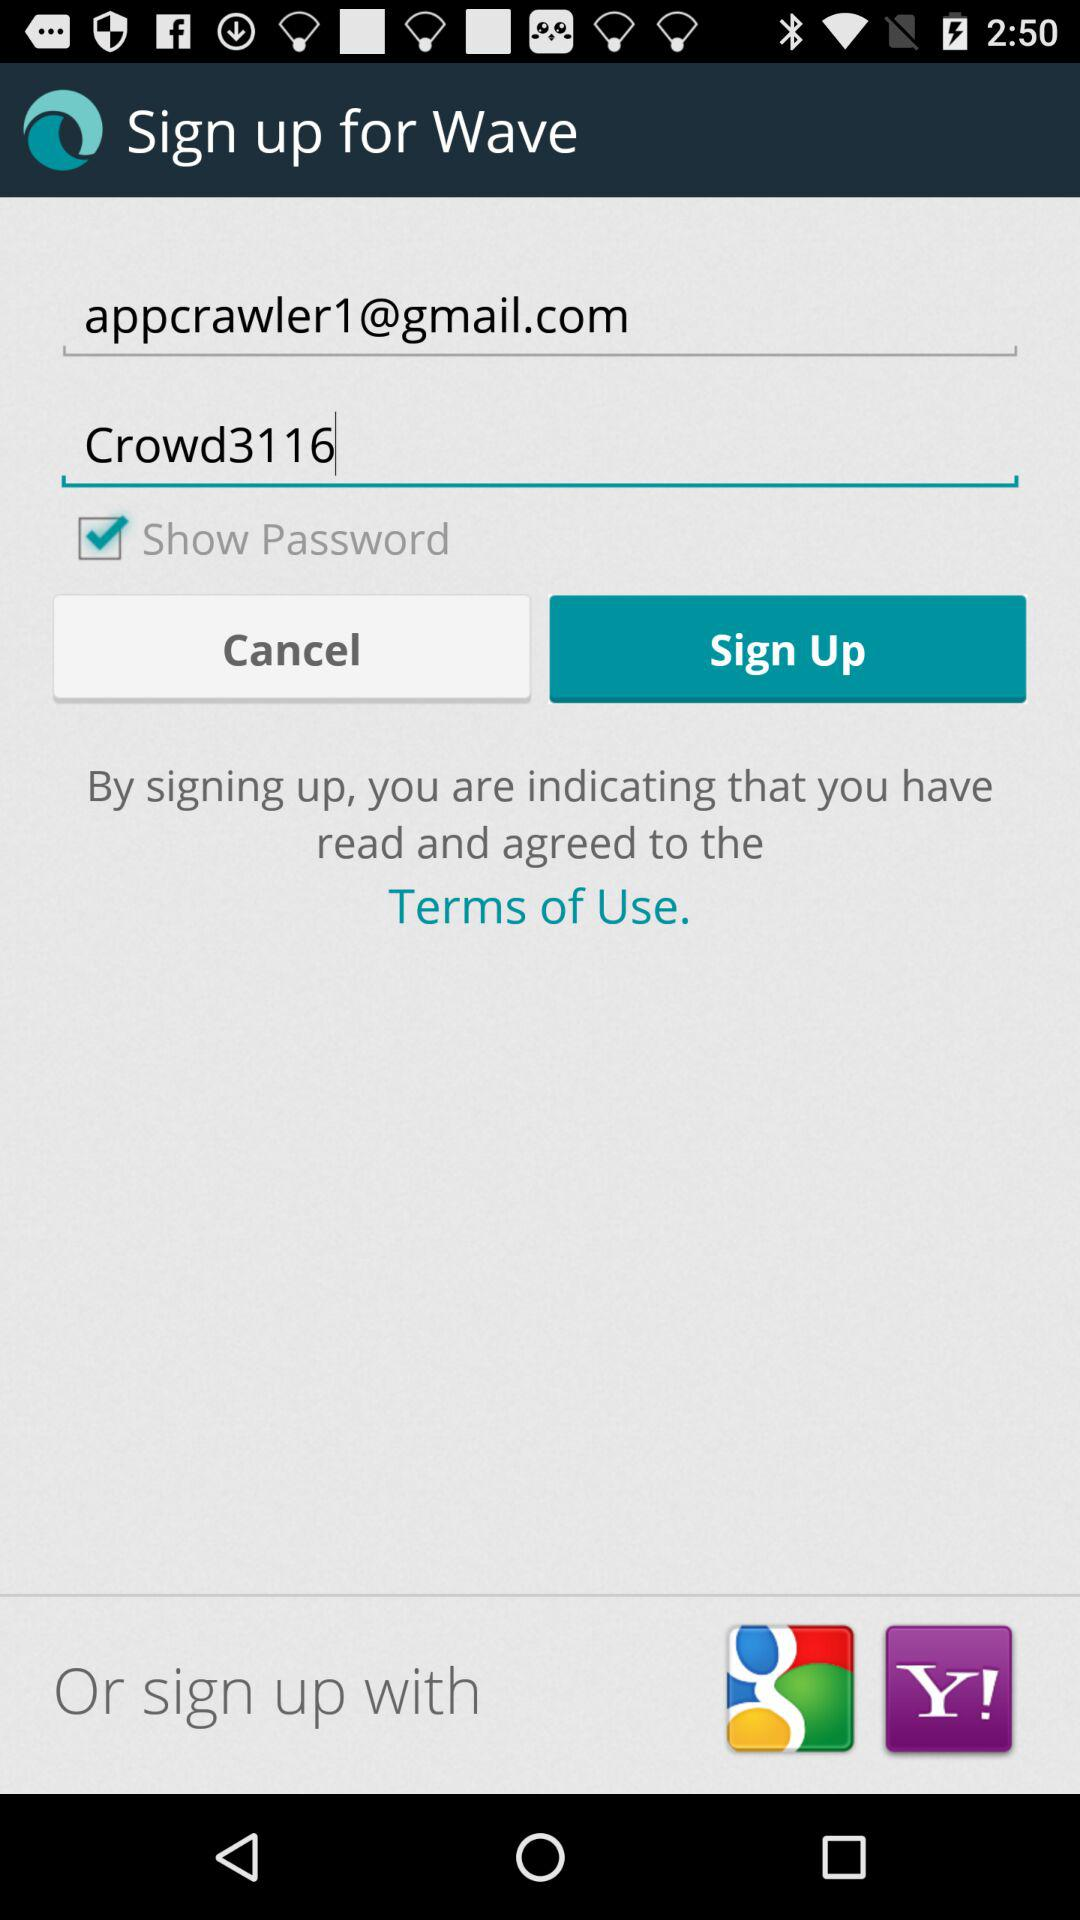What is the given email address? The given email address is appcrawler1@gmail.com. 